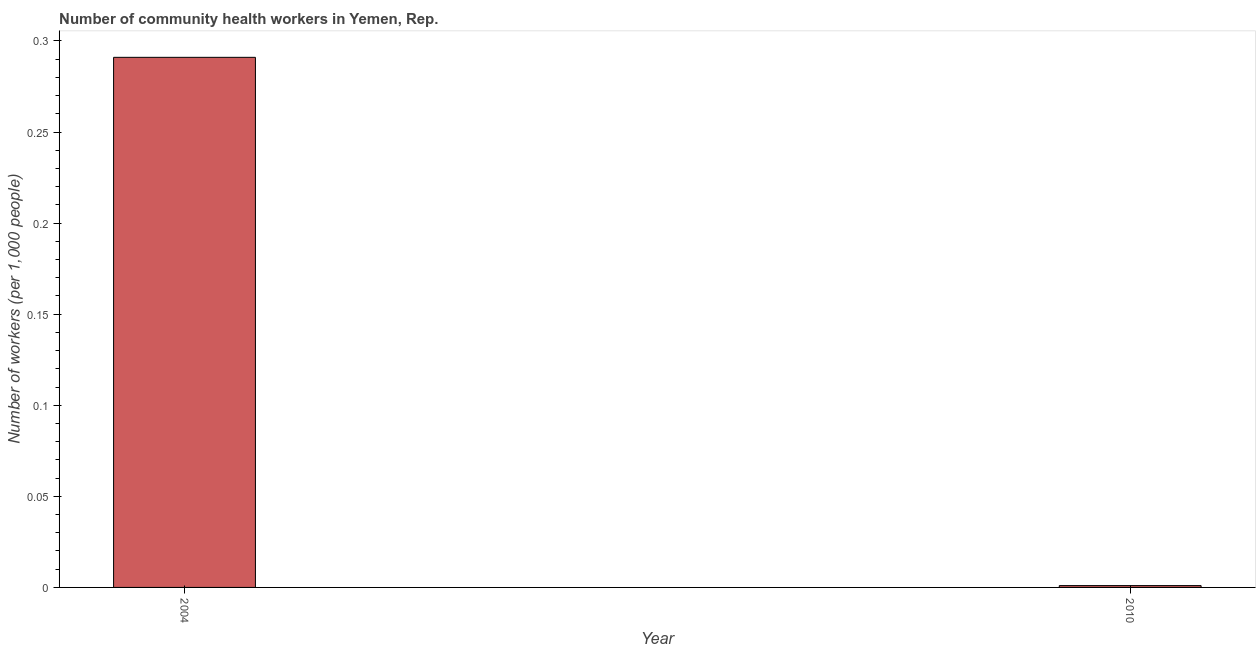What is the title of the graph?
Offer a terse response. Number of community health workers in Yemen, Rep. What is the label or title of the X-axis?
Your response must be concise. Year. What is the label or title of the Y-axis?
Offer a terse response. Number of workers (per 1,0 people). What is the number of community health workers in 2010?
Give a very brief answer. 0. Across all years, what is the maximum number of community health workers?
Provide a short and direct response. 0.29. Across all years, what is the minimum number of community health workers?
Your answer should be very brief. 0. In which year was the number of community health workers minimum?
Give a very brief answer. 2010. What is the sum of the number of community health workers?
Make the answer very short. 0.29. What is the difference between the number of community health workers in 2004 and 2010?
Provide a succinct answer. 0.29. What is the average number of community health workers per year?
Your response must be concise. 0.15. What is the median number of community health workers?
Ensure brevity in your answer.  0.15. In how many years, is the number of community health workers greater than 0.05 ?
Keep it short and to the point. 1. What is the ratio of the number of community health workers in 2004 to that in 2010?
Make the answer very short. 291. Are all the bars in the graph horizontal?
Your answer should be very brief. No. What is the Number of workers (per 1,000 people) in 2004?
Make the answer very short. 0.29. What is the Number of workers (per 1,000 people) of 2010?
Ensure brevity in your answer.  0. What is the difference between the Number of workers (per 1,000 people) in 2004 and 2010?
Provide a short and direct response. 0.29. What is the ratio of the Number of workers (per 1,000 people) in 2004 to that in 2010?
Your answer should be very brief. 291. 